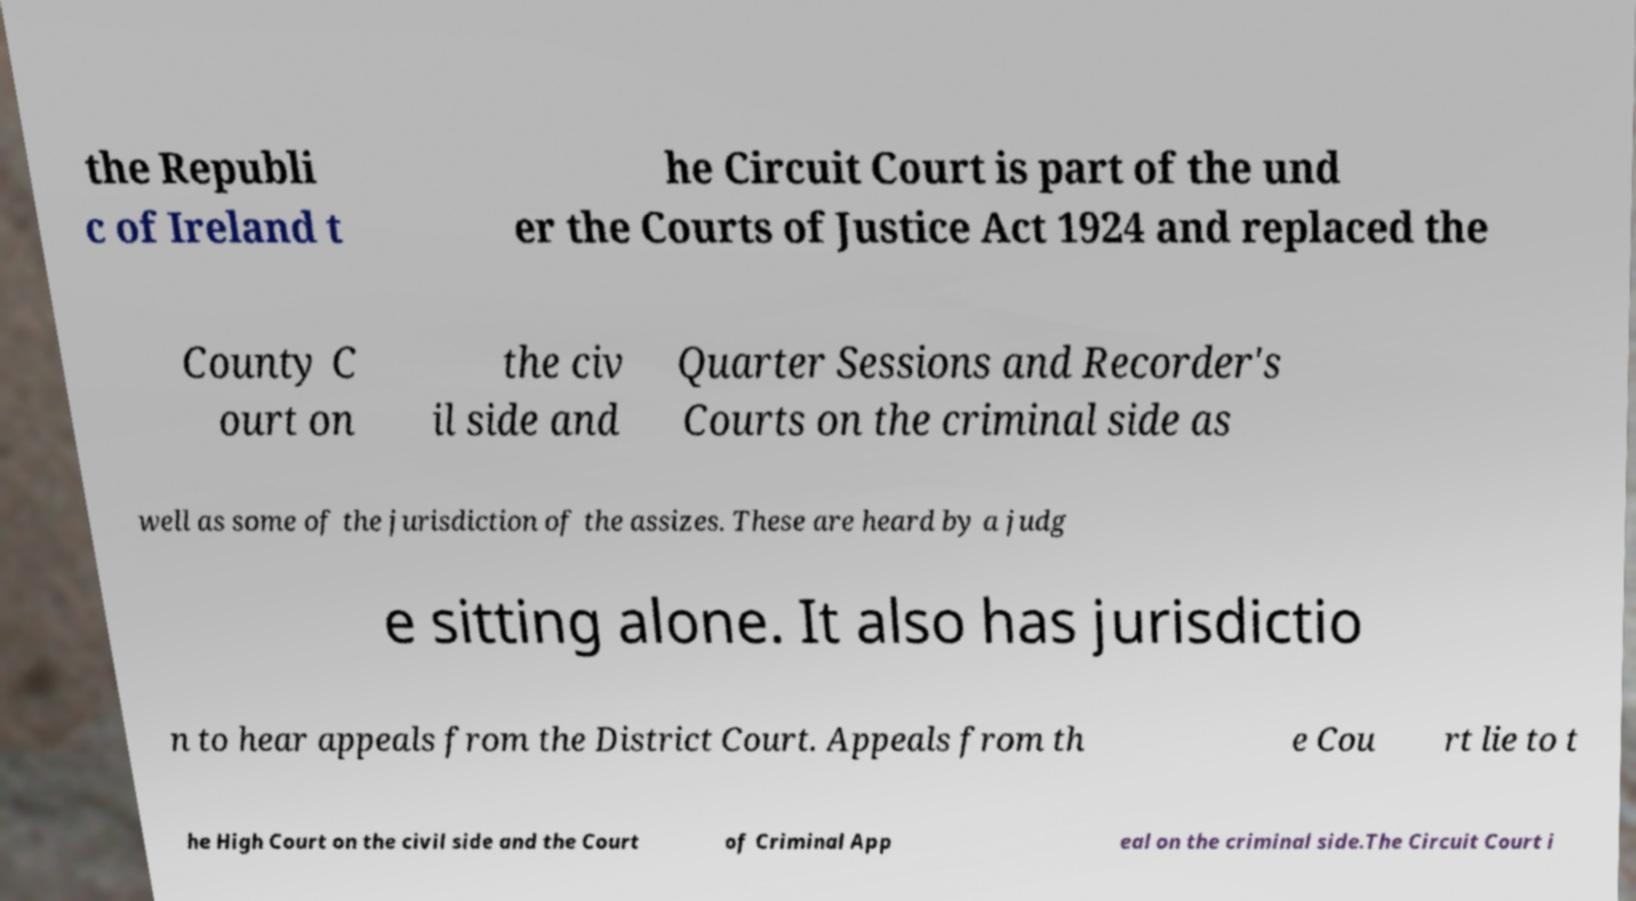For documentation purposes, I need the text within this image transcribed. Could you provide that? the Republi c of Ireland t he Circuit Court is part of the und er the Courts of Justice Act 1924 and replaced the County C ourt on the civ il side and Quarter Sessions and Recorder's Courts on the criminal side as well as some of the jurisdiction of the assizes. These are heard by a judg e sitting alone. It also has jurisdictio n to hear appeals from the District Court. Appeals from th e Cou rt lie to t he High Court on the civil side and the Court of Criminal App eal on the criminal side.The Circuit Court i 